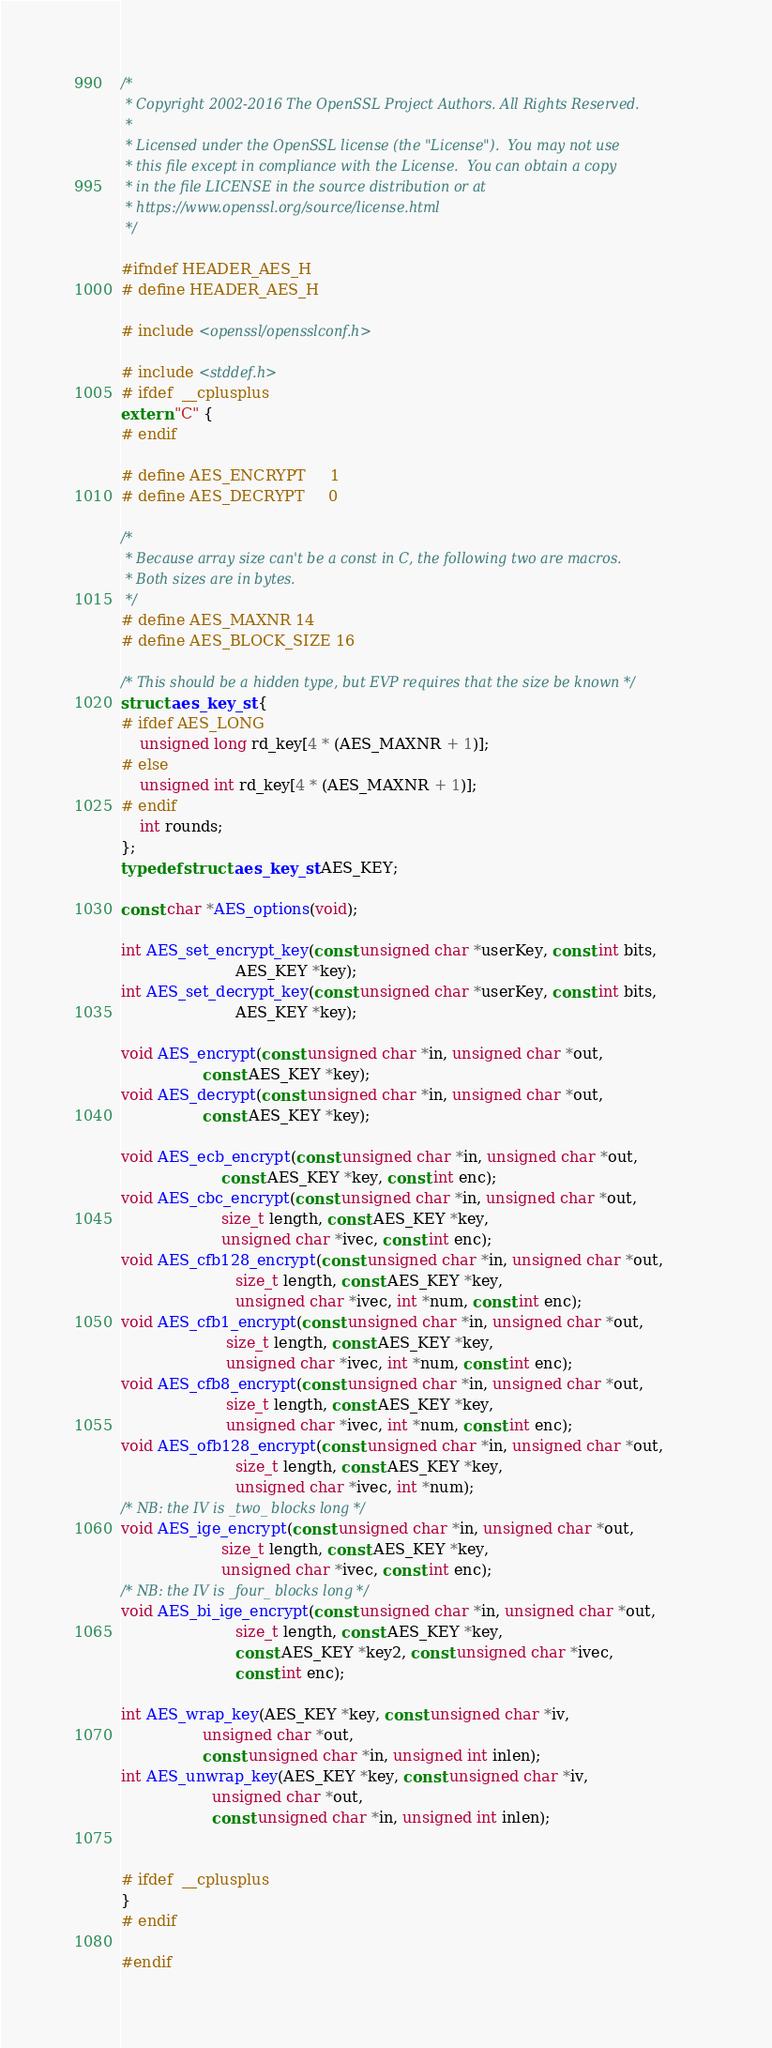<code> <loc_0><loc_0><loc_500><loc_500><_C_>/*
 * Copyright 2002-2016 The OpenSSL Project Authors. All Rights Reserved.
 *
 * Licensed under the OpenSSL license (the "License").  You may not use
 * this file except in compliance with the License.  You can obtain a copy
 * in the file LICENSE in the source distribution or at
 * https://www.openssl.org/source/license.html
 */

#ifndef HEADER_AES_H
# define HEADER_AES_H

# include <openssl/opensslconf.h>

# include <stddef.h>
# ifdef  __cplusplus
extern "C" {
# endif

# define AES_ENCRYPT     1
# define AES_DECRYPT     0

/*
 * Because array size can't be a const in C, the following two are macros.
 * Both sizes are in bytes.
 */
# define AES_MAXNR 14
# define AES_BLOCK_SIZE 16

/* This should be a hidden type, but EVP requires that the size be known */
struct aes_key_st {
# ifdef AES_LONG
    unsigned long rd_key[4 * (AES_MAXNR + 1)];
# else
    unsigned int rd_key[4 * (AES_MAXNR + 1)];
# endif
    int rounds;
};
typedef struct aes_key_st AES_KEY;

const char *AES_options(void);

int AES_set_encrypt_key(const unsigned char *userKey, const int bits,
                        AES_KEY *key);
int AES_set_decrypt_key(const unsigned char *userKey, const int bits,
                        AES_KEY *key);

void AES_encrypt(const unsigned char *in, unsigned char *out,
                 const AES_KEY *key);
void AES_decrypt(const unsigned char *in, unsigned char *out,
                 const AES_KEY *key);

void AES_ecb_encrypt(const unsigned char *in, unsigned char *out,
                     const AES_KEY *key, const int enc);
void AES_cbc_encrypt(const unsigned char *in, unsigned char *out,
                     size_t length, const AES_KEY *key,
                     unsigned char *ivec, const int enc);
void AES_cfb128_encrypt(const unsigned char *in, unsigned char *out,
                        size_t length, const AES_KEY *key,
                        unsigned char *ivec, int *num, const int enc);
void AES_cfb1_encrypt(const unsigned char *in, unsigned char *out,
                      size_t length, const AES_KEY *key,
                      unsigned char *ivec, int *num, const int enc);
void AES_cfb8_encrypt(const unsigned char *in, unsigned char *out,
                      size_t length, const AES_KEY *key,
                      unsigned char *ivec, int *num, const int enc);
void AES_ofb128_encrypt(const unsigned char *in, unsigned char *out,
                        size_t length, const AES_KEY *key,
                        unsigned char *ivec, int *num);
/* NB: the IV is _two_ blocks long */
void AES_ige_encrypt(const unsigned char *in, unsigned char *out,
                     size_t length, const AES_KEY *key,
                     unsigned char *ivec, const int enc);
/* NB: the IV is _four_ blocks long */
void AES_bi_ige_encrypt(const unsigned char *in, unsigned char *out,
                        size_t length, const AES_KEY *key,
                        const AES_KEY *key2, const unsigned char *ivec,
                        const int enc);

int AES_wrap_key(AES_KEY *key, const unsigned char *iv,
                 unsigned char *out,
                 const unsigned char *in, unsigned int inlen);
int AES_unwrap_key(AES_KEY *key, const unsigned char *iv,
                   unsigned char *out,
                   const unsigned char *in, unsigned int inlen);


# ifdef  __cplusplus
}
# endif

#endif
</code> 